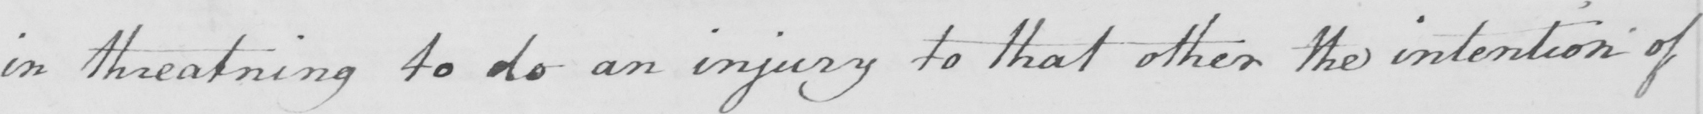Please transcribe the handwritten text in this image. in threatning to do an injury to that other the intention of 